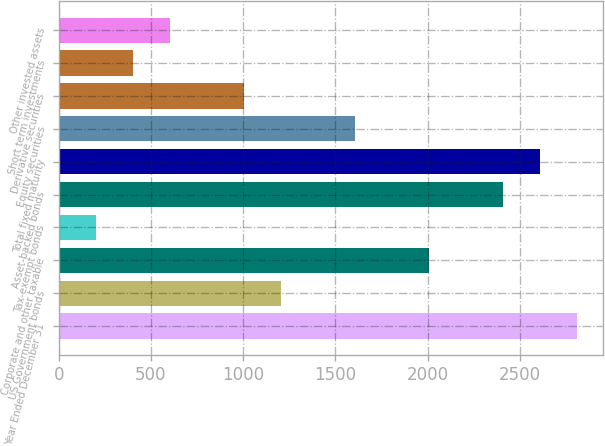Convert chart. <chart><loc_0><loc_0><loc_500><loc_500><bar_chart><fcel>Year Ended December 31<fcel>US Government bonds<fcel>Corporate and other taxable<fcel>Tax-exempt bonds<fcel>Asset-backed bonds<fcel>Total fixed maturity<fcel>Equity securities<fcel>Derivative securities<fcel>Short term investments<fcel>Other invested assets<nl><fcel>2809<fcel>1205<fcel>2007<fcel>202.5<fcel>2408<fcel>2608.5<fcel>1606<fcel>1004.5<fcel>403<fcel>603.5<nl></chart> 